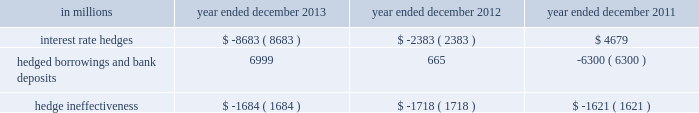Notes to consolidated financial statements hedge accounting the firm applies hedge accounting for ( i ) certain interest rate swaps used to manage the interest rate exposure of certain fixed-rate unsecured long-term and short-term borrowings and certain fixed-rate certificates of deposit , ( ii ) certain foreign currency forward contracts and foreign currency-denominated debt used to manage foreign currency exposures on the firm 2019s net investment in certain non-u.s .
Operations and ( iii ) certain commodities-related swap and forward contracts used to manage the exposure to the variability in cash flows associated with the forecasted sales of certain energy commodities by one of the firm 2019s consolidated investments .
To qualify for hedge accounting , the derivative hedge must be highly effective at reducing the risk from the exposure being hedged .
Additionally , the firm must formally document the hedging relationship at inception and test the hedging relationship at least on a quarterly basis to ensure the derivative hedge continues to be highly effective over the life of the hedging relationship .
Fair value hedges the firm designates certain interest rate swaps as fair value hedges .
These interest rate swaps hedge changes in fair value attributable to the designated benchmark interest rate ( e.g. , london interbank offered rate ( libor ) or ois ) , effectively converting a substantial portion of fixed-rate obligations into floating-rate obligations .
The firm applies a statistical method that utilizes regression analysis when assessing the effectiveness of its fair value hedging relationships in achieving offsetting changes in the fair values of the hedging instrument and the risk being hedged ( i.e. , interest rate risk ) .
An interest rate swap is considered highly effective in offsetting changes in fair value attributable to changes in the hedged risk when the regression analysis results in a coefficient of determination of 80% ( 80 % ) or greater and a slope between 80% ( 80 % ) and 125% ( 125 % ) .
For qualifying fair value hedges , gains or losses on derivatives are included in 201cinterest expense . 201d the change in fair value of the hedged item attributable to the risk being hedged is reported as an adjustment to its carrying value and is subsequently amortized into interest expense over its remaining life .
Gains or losses resulting from hedge ineffectiveness are included in 201cinterest expense . 201d when a derivative is no longer designated as a hedge , any remaining difference between the carrying value and par value of the hedged item is amortized to interest expense over the remaining life of the hedged item using the effective interest method .
See note 23 for further information about interest income and interest expense .
The table below presents the gains/ ( losses ) from interest rate derivatives accounted for as hedges , the related hedged borrowings and bank deposits , and the hedge ineffectiveness on these derivatives , which primarily consists of amortization of prepaid credit spreads resulting from the passage of time. .
Goldman sachs 2013 annual report 149 .
In millions for 2013 , 2012 , and 2011 , what was the maximum interest rate hedge? 
Computations: table_max(interest rate hedges, none)
Answer: 4679.0. Notes to consolidated financial statements hedge accounting the firm applies hedge accounting for ( i ) certain interest rate swaps used to manage the interest rate exposure of certain fixed-rate unsecured long-term and short-term borrowings and certain fixed-rate certificates of deposit , ( ii ) certain foreign currency forward contracts and foreign currency-denominated debt used to manage foreign currency exposures on the firm 2019s net investment in certain non-u.s .
Operations and ( iii ) certain commodities-related swap and forward contracts used to manage the exposure to the variability in cash flows associated with the forecasted sales of certain energy commodities by one of the firm 2019s consolidated investments .
To qualify for hedge accounting , the derivative hedge must be highly effective at reducing the risk from the exposure being hedged .
Additionally , the firm must formally document the hedging relationship at inception and test the hedging relationship at least on a quarterly basis to ensure the derivative hedge continues to be highly effective over the life of the hedging relationship .
Fair value hedges the firm designates certain interest rate swaps as fair value hedges .
These interest rate swaps hedge changes in fair value attributable to the designated benchmark interest rate ( e.g. , london interbank offered rate ( libor ) or ois ) , effectively converting a substantial portion of fixed-rate obligations into floating-rate obligations .
The firm applies a statistical method that utilizes regression analysis when assessing the effectiveness of its fair value hedging relationships in achieving offsetting changes in the fair values of the hedging instrument and the risk being hedged ( i.e. , interest rate risk ) .
An interest rate swap is considered highly effective in offsetting changes in fair value attributable to changes in the hedged risk when the regression analysis results in a coefficient of determination of 80% ( 80 % ) or greater and a slope between 80% ( 80 % ) and 125% ( 125 % ) .
For qualifying fair value hedges , gains or losses on derivatives are included in 201cinterest expense . 201d the change in fair value of the hedged item attributable to the risk being hedged is reported as an adjustment to its carrying value and is subsequently amortized into interest expense over its remaining life .
Gains or losses resulting from hedge ineffectiveness are included in 201cinterest expense . 201d when a derivative is no longer designated as a hedge , any remaining difference between the carrying value and par value of the hedged item is amortized to interest expense over the remaining life of the hedged item using the effective interest method .
See note 23 for further information about interest income and interest expense .
The table below presents the gains/ ( losses ) from interest rate derivatives accounted for as hedges , the related hedged borrowings and bank deposits , and the hedge ineffectiveness on these derivatives , which primarily consists of amortization of prepaid credit spreads resulting from the passage of time. .
Goldman sachs 2013 annual report 149 .
What is the range in percentage points of the slope in the coefficient of determination? 
Computations: (125 - 80)
Answer: 45.0. 